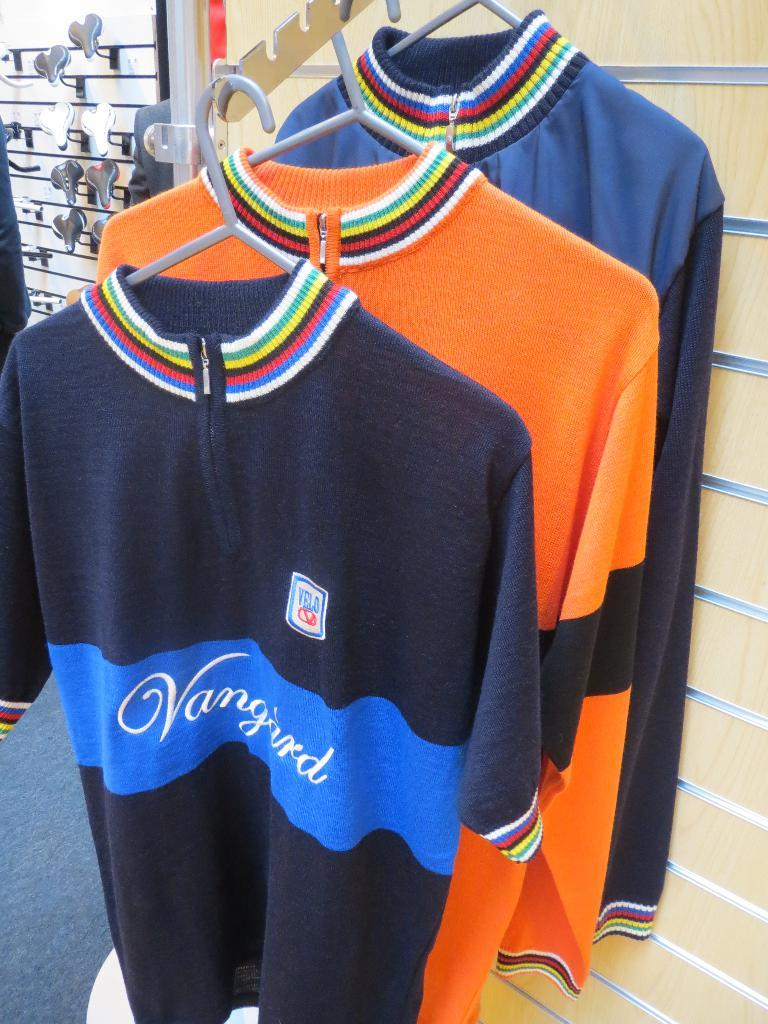<image>
Provide a brief description of the given image. The sweaters on display in a store have the name Vangard. 